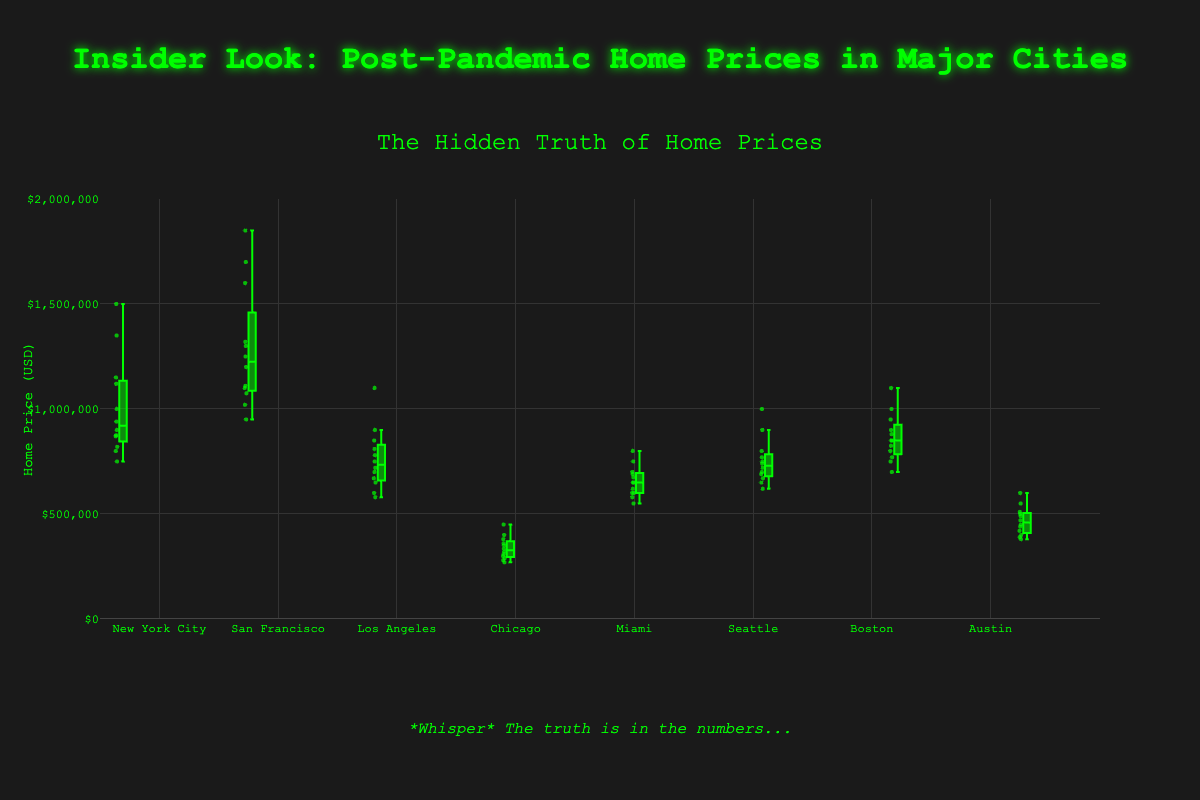What is the title of the figure? The title of the figure is displayed at the top and reads "Insider Look: Post-Pandemic Home Prices in Major Cities".
Answer: Insider Look: Post-Pandemic Home Prices in Major Cities What is the main color used for the box plots? The box plots use a green color that appears consistently across all the boxes representing different cities.
Answer: Green Which city shows the highest median home price post-pandemic? To find the city with the highest median home price, look for the box plot with the highest central line (representing the median). San Francisco's median line is the highest.
Answer: San Francisco What is the approximate range of home prices in Chicago? Chicago's box plot stretches from about 270,000 to 450,000. The exact range can be estimated by observing the minimum and maximum values represented as the bottom and top whiskers of the box plot.
Answer: 270,000 to 450,000 Which two cities have the most similar median home prices? Compare the central lines of the boxes (medians). New York City and Boston have nearly identical median values, both around the 900,000 mark.
Answer: New York City and Boston What are the upper and lower quartiles for Los Angeles? The box plot for Los Angeles indicates the upper quartile (top of the box) is around 850,000, and the lower quartile (bottom of the box) is around 670,000.
Answer: Upper: 850,000, Lower: 670,000 How does the spread of home prices in Miami compare to that in Seattle? The spread of home prices can be assessed by the height of the box plots. Miami's box plot is shorter, indicating a narrower spread, while Seattle's box plot is taller, indicating a wider spread.
Answer: Miami has a narrower spread than Seattle In which city do home prices show the greatest variability? Variability can be observed by the length of the whiskers. San Francisco's whiskers are the longest, suggesting the greatest variability in home prices.
Answer: San Francisco Which city has the highest minimum home price? The bottom whiskers indicate the minimum prices. San Francisco has the highest minimum price, as its bottom whisker starts around 950,000.
Answer: San Francisco 